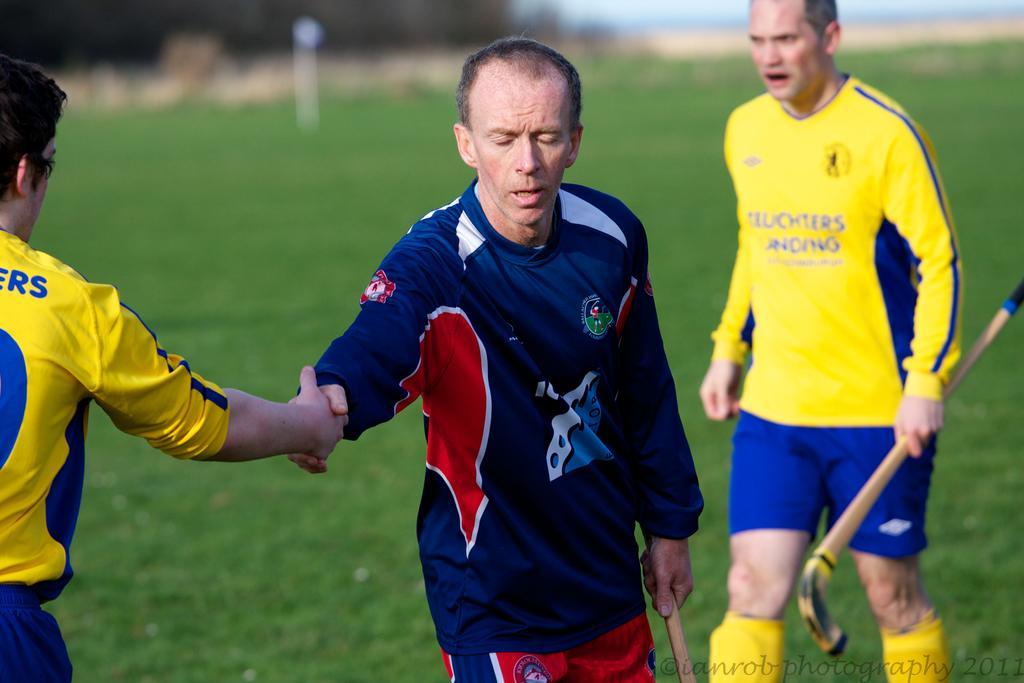Describe this image in one or two sentences. In this picture we can three people on the ground, two people are holding sticks and in the background we can see trees, sky and it is blurry, in the bottom right we can see some text on it. 